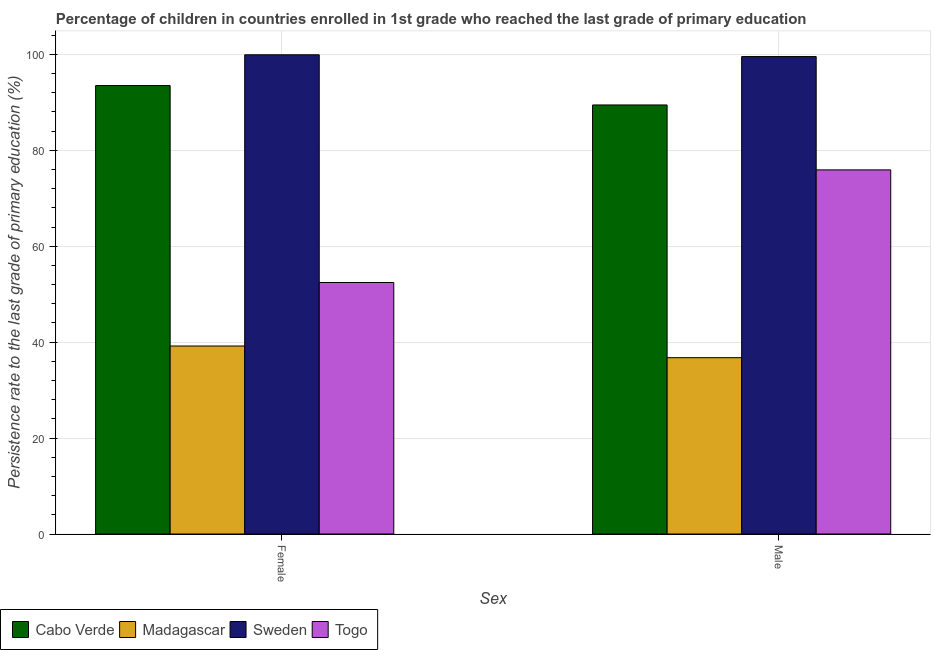Are the number of bars per tick equal to the number of legend labels?
Offer a very short reply. Yes. What is the persistence rate of male students in Cabo Verde?
Provide a short and direct response. 89.45. Across all countries, what is the maximum persistence rate of male students?
Keep it short and to the point. 99.54. Across all countries, what is the minimum persistence rate of male students?
Your answer should be very brief. 36.76. In which country was the persistence rate of male students minimum?
Ensure brevity in your answer.  Madagascar. What is the total persistence rate of female students in the graph?
Ensure brevity in your answer.  285.03. What is the difference between the persistence rate of female students in Madagascar and that in Sweden?
Offer a very short reply. -60.72. What is the difference between the persistence rate of male students in Togo and the persistence rate of female students in Cabo Verde?
Make the answer very short. -17.58. What is the average persistence rate of female students per country?
Provide a short and direct response. 71.26. What is the difference between the persistence rate of male students and persistence rate of female students in Madagascar?
Offer a terse response. -2.43. In how many countries, is the persistence rate of male students greater than 96 %?
Provide a succinct answer. 1. What is the ratio of the persistence rate of male students in Sweden to that in Madagascar?
Ensure brevity in your answer.  2.71. Is the persistence rate of female students in Togo less than that in Sweden?
Provide a short and direct response. Yes. In how many countries, is the persistence rate of male students greater than the average persistence rate of male students taken over all countries?
Ensure brevity in your answer.  3. What does the 2nd bar from the left in Male represents?
Your answer should be very brief. Madagascar. Are all the bars in the graph horizontal?
Your response must be concise. No. How many countries are there in the graph?
Provide a short and direct response. 4. Does the graph contain any zero values?
Give a very brief answer. No. Does the graph contain grids?
Give a very brief answer. Yes. What is the title of the graph?
Provide a succinct answer. Percentage of children in countries enrolled in 1st grade who reached the last grade of primary education. What is the label or title of the X-axis?
Ensure brevity in your answer.  Sex. What is the label or title of the Y-axis?
Your answer should be compact. Persistence rate to the last grade of primary education (%). What is the Persistence rate to the last grade of primary education (%) of Cabo Verde in Female?
Provide a succinct answer. 93.49. What is the Persistence rate to the last grade of primary education (%) in Madagascar in Female?
Offer a terse response. 39.19. What is the Persistence rate to the last grade of primary education (%) of Sweden in Female?
Keep it short and to the point. 99.91. What is the Persistence rate to the last grade of primary education (%) of Togo in Female?
Provide a short and direct response. 52.43. What is the Persistence rate to the last grade of primary education (%) of Cabo Verde in Male?
Your answer should be very brief. 89.45. What is the Persistence rate to the last grade of primary education (%) of Madagascar in Male?
Your answer should be compact. 36.76. What is the Persistence rate to the last grade of primary education (%) in Sweden in Male?
Offer a terse response. 99.54. What is the Persistence rate to the last grade of primary education (%) in Togo in Male?
Make the answer very short. 75.91. Across all Sex, what is the maximum Persistence rate to the last grade of primary education (%) of Cabo Verde?
Provide a succinct answer. 93.49. Across all Sex, what is the maximum Persistence rate to the last grade of primary education (%) in Madagascar?
Your answer should be compact. 39.19. Across all Sex, what is the maximum Persistence rate to the last grade of primary education (%) in Sweden?
Give a very brief answer. 99.91. Across all Sex, what is the maximum Persistence rate to the last grade of primary education (%) in Togo?
Your answer should be very brief. 75.91. Across all Sex, what is the minimum Persistence rate to the last grade of primary education (%) in Cabo Verde?
Make the answer very short. 89.45. Across all Sex, what is the minimum Persistence rate to the last grade of primary education (%) in Madagascar?
Make the answer very short. 36.76. Across all Sex, what is the minimum Persistence rate to the last grade of primary education (%) of Sweden?
Your response must be concise. 99.54. Across all Sex, what is the minimum Persistence rate to the last grade of primary education (%) of Togo?
Give a very brief answer. 52.43. What is the total Persistence rate to the last grade of primary education (%) of Cabo Verde in the graph?
Your answer should be very brief. 182.94. What is the total Persistence rate to the last grade of primary education (%) of Madagascar in the graph?
Your answer should be very brief. 75.96. What is the total Persistence rate to the last grade of primary education (%) of Sweden in the graph?
Keep it short and to the point. 199.45. What is the total Persistence rate to the last grade of primary education (%) of Togo in the graph?
Make the answer very short. 128.35. What is the difference between the Persistence rate to the last grade of primary education (%) in Cabo Verde in Female and that in Male?
Give a very brief answer. 4.04. What is the difference between the Persistence rate to the last grade of primary education (%) in Madagascar in Female and that in Male?
Provide a short and direct response. 2.43. What is the difference between the Persistence rate to the last grade of primary education (%) in Sweden in Female and that in Male?
Your answer should be compact. 0.37. What is the difference between the Persistence rate to the last grade of primary education (%) in Togo in Female and that in Male?
Keep it short and to the point. -23.48. What is the difference between the Persistence rate to the last grade of primary education (%) of Cabo Verde in Female and the Persistence rate to the last grade of primary education (%) of Madagascar in Male?
Offer a very short reply. 56.73. What is the difference between the Persistence rate to the last grade of primary education (%) in Cabo Verde in Female and the Persistence rate to the last grade of primary education (%) in Sweden in Male?
Ensure brevity in your answer.  -6.05. What is the difference between the Persistence rate to the last grade of primary education (%) in Cabo Verde in Female and the Persistence rate to the last grade of primary education (%) in Togo in Male?
Make the answer very short. 17.58. What is the difference between the Persistence rate to the last grade of primary education (%) of Madagascar in Female and the Persistence rate to the last grade of primary education (%) of Sweden in Male?
Make the answer very short. -60.35. What is the difference between the Persistence rate to the last grade of primary education (%) of Madagascar in Female and the Persistence rate to the last grade of primary education (%) of Togo in Male?
Offer a very short reply. -36.72. What is the difference between the Persistence rate to the last grade of primary education (%) in Sweden in Female and the Persistence rate to the last grade of primary education (%) in Togo in Male?
Ensure brevity in your answer.  24. What is the average Persistence rate to the last grade of primary education (%) in Cabo Verde per Sex?
Provide a short and direct response. 91.47. What is the average Persistence rate to the last grade of primary education (%) in Madagascar per Sex?
Provide a short and direct response. 37.98. What is the average Persistence rate to the last grade of primary education (%) in Sweden per Sex?
Offer a terse response. 99.73. What is the average Persistence rate to the last grade of primary education (%) of Togo per Sex?
Ensure brevity in your answer.  64.17. What is the difference between the Persistence rate to the last grade of primary education (%) in Cabo Verde and Persistence rate to the last grade of primary education (%) in Madagascar in Female?
Your response must be concise. 54.3. What is the difference between the Persistence rate to the last grade of primary education (%) in Cabo Verde and Persistence rate to the last grade of primary education (%) in Sweden in Female?
Make the answer very short. -6.42. What is the difference between the Persistence rate to the last grade of primary education (%) in Cabo Verde and Persistence rate to the last grade of primary education (%) in Togo in Female?
Provide a succinct answer. 41.06. What is the difference between the Persistence rate to the last grade of primary education (%) of Madagascar and Persistence rate to the last grade of primary education (%) of Sweden in Female?
Provide a succinct answer. -60.72. What is the difference between the Persistence rate to the last grade of primary education (%) of Madagascar and Persistence rate to the last grade of primary education (%) of Togo in Female?
Keep it short and to the point. -13.24. What is the difference between the Persistence rate to the last grade of primary education (%) of Sweden and Persistence rate to the last grade of primary education (%) of Togo in Female?
Offer a very short reply. 47.48. What is the difference between the Persistence rate to the last grade of primary education (%) in Cabo Verde and Persistence rate to the last grade of primary education (%) in Madagascar in Male?
Make the answer very short. 52.69. What is the difference between the Persistence rate to the last grade of primary education (%) in Cabo Verde and Persistence rate to the last grade of primary education (%) in Sweden in Male?
Keep it short and to the point. -10.09. What is the difference between the Persistence rate to the last grade of primary education (%) in Cabo Verde and Persistence rate to the last grade of primary education (%) in Togo in Male?
Provide a succinct answer. 13.54. What is the difference between the Persistence rate to the last grade of primary education (%) of Madagascar and Persistence rate to the last grade of primary education (%) of Sweden in Male?
Provide a succinct answer. -62.78. What is the difference between the Persistence rate to the last grade of primary education (%) in Madagascar and Persistence rate to the last grade of primary education (%) in Togo in Male?
Your response must be concise. -39.15. What is the difference between the Persistence rate to the last grade of primary education (%) in Sweden and Persistence rate to the last grade of primary education (%) in Togo in Male?
Your response must be concise. 23.63. What is the ratio of the Persistence rate to the last grade of primary education (%) in Cabo Verde in Female to that in Male?
Offer a terse response. 1.05. What is the ratio of the Persistence rate to the last grade of primary education (%) of Madagascar in Female to that in Male?
Ensure brevity in your answer.  1.07. What is the ratio of the Persistence rate to the last grade of primary education (%) in Togo in Female to that in Male?
Your answer should be compact. 0.69. What is the difference between the highest and the second highest Persistence rate to the last grade of primary education (%) in Cabo Verde?
Give a very brief answer. 4.04. What is the difference between the highest and the second highest Persistence rate to the last grade of primary education (%) of Madagascar?
Give a very brief answer. 2.43. What is the difference between the highest and the second highest Persistence rate to the last grade of primary education (%) of Sweden?
Make the answer very short. 0.37. What is the difference between the highest and the second highest Persistence rate to the last grade of primary education (%) of Togo?
Offer a very short reply. 23.48. What is the difference between the highest and the lowest Persistence rate to the last grade of primary education (%) of Cabo Verde?
Make the answer very short. 4.04. What is the difference between the highest and the lowest Persistence rate to the last grade of primary education (%) in Madagascar?
Your response must be concise. 2.43. What is the difference between the highest and the lowest Persistence rate to the last grade of primary education (%) of Sweden?
Make the answer very short. 0.37. What is the difference between the highest and the lowest Persistence rate to the last grade of primary education (%) in Togo?
Give a very brief answer. 23.48. 